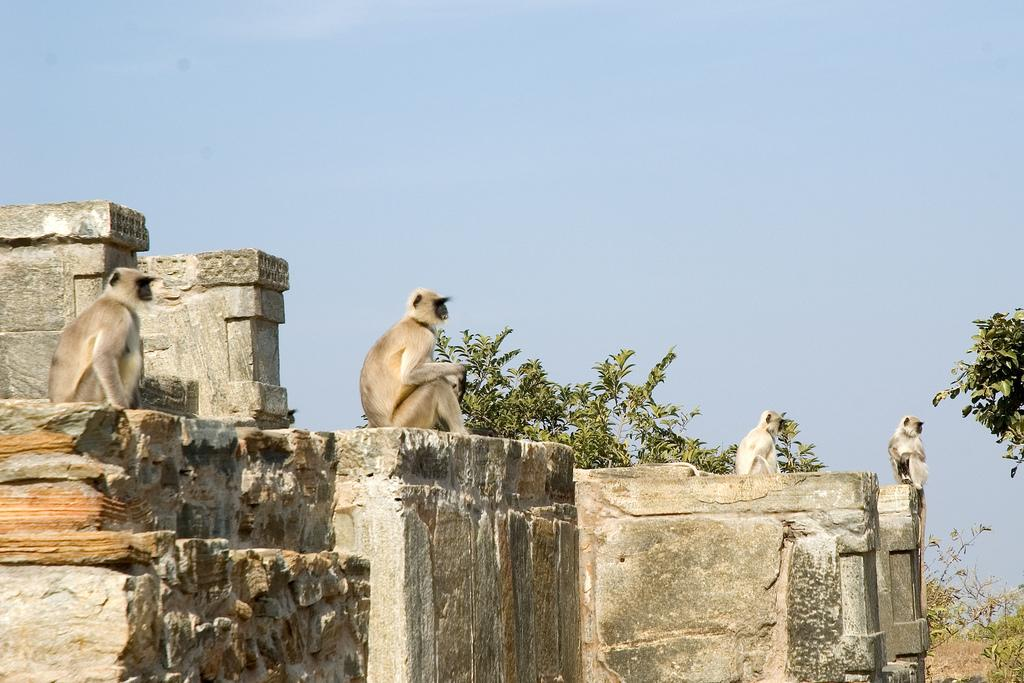What animals are on the rock in the image? There are monkeys on a rock in the image. What can be seen in the background of the image? There are trees in the background of the image. What is visible at the top of the image? The sky is visible at the top of the image. What type of thunder can be heard in the image? There is no sound present in the image, so it is not possible to determine if any thunder can be heard. 